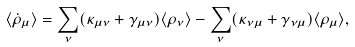<formula> <loc_0><loc_0><loc_500><loc_500>\langle \dot { \rho } _ { \mu } \rangle = \sum _ { \nu } ( \kappa _ { \mu \nu } + \gamma _ { \mu \nu } ) \langle \rho _ { \nu } \rangle - \sum _ { \nu } ( \kappa _ { \nu \mu } + \gamma _ { \nu \mu } ) \langle \rho _ { \mu } \rangle ,</formula> 